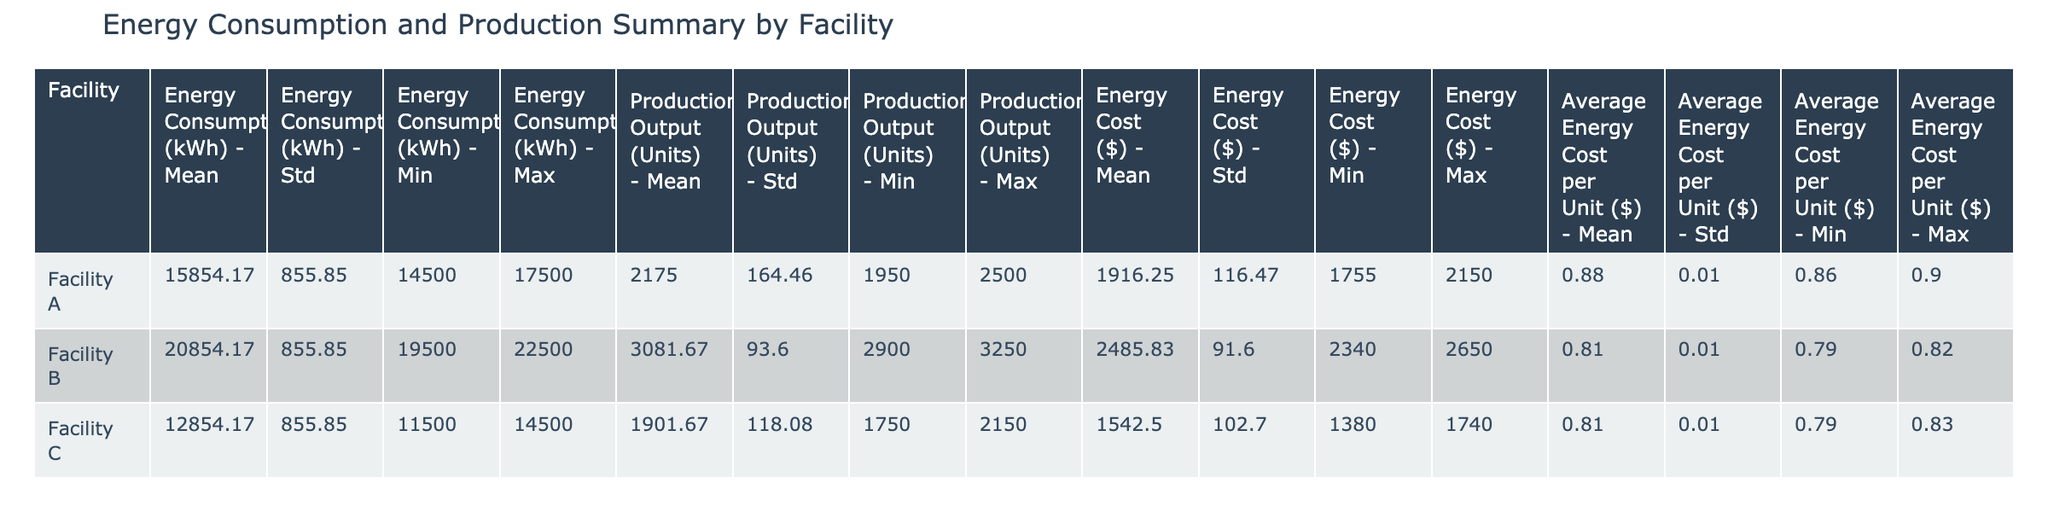What is the average energy consumption for Facility A? To find the average energy consumption for Facility A, we sum the energy consumption values for each month (15000 + 14500 + 16000 + 15500 + 16500 + 17000 + 17500 + 16000 + 15000 + 15500 + 15750 + 16000 = 187500) and divide by 12 (months), resulting in an average of 15625 kWh.
Answer: 15625 kWh Which facility had the highest average energy cost per unit? We compare the average energy cost per unit for each facility: Facility A (0.87), Facility B (0.81), and Facility C (0.81). Facility A has the highest average energy cost per unit.
Answer: Facility A Did Facility B show an increase or decrease in energy consumption from January to December? We compare the energy consumption values for Facility B from January (20000 kWh) to December (21000 kWh). Since December's value is higher than January's, energy consumption increased.
Answer: Increase What is the total production output for Facility C over the year? To find the total production output for Facility C, we sum the production output values for each month (1800 + 1750 + 1900 + 1850 + 1950 + 2100 + 2150 + 1900 + 1800 + 1850 + 1870 + 1900 = 23570).
Answer: 23570 units What is the difference in average energy consumption between Facility A and Facility B? We first find the average energy consumption for both facilities: Facility A's average is 15625 kWh, Facility B's average is 21000 kWh. The difference is 21000 - 15625 = 5375 kWh.
Answer: 5375 kWh Is the average energy cost per unit for Facility C higher than for Facility A? We compare the average energy cost per unit for both facilities: Facility C (0.81) and Facility A (0.87). Since 0.87 is greater than 0.81, Facility C's average cost is not higher than Facility A's.
Answer: No What is the maximum energy consumption recorded for Facility B? Looking at the data for Facility B, the maximum energy consumption value is 22500 kWh, recorded in July.
Answer: 22500 kWh Calculate the average energy cost across all facilities for the year. First, we sum the average energy costs: Facility A (0.87), Facility B (0.81), Facility C (0.81). Then divide the total by 3: (0.87 + 0.81 + 0.81) / 3 = 0.8433, rounded to 0.84.
Answer: 0.84 